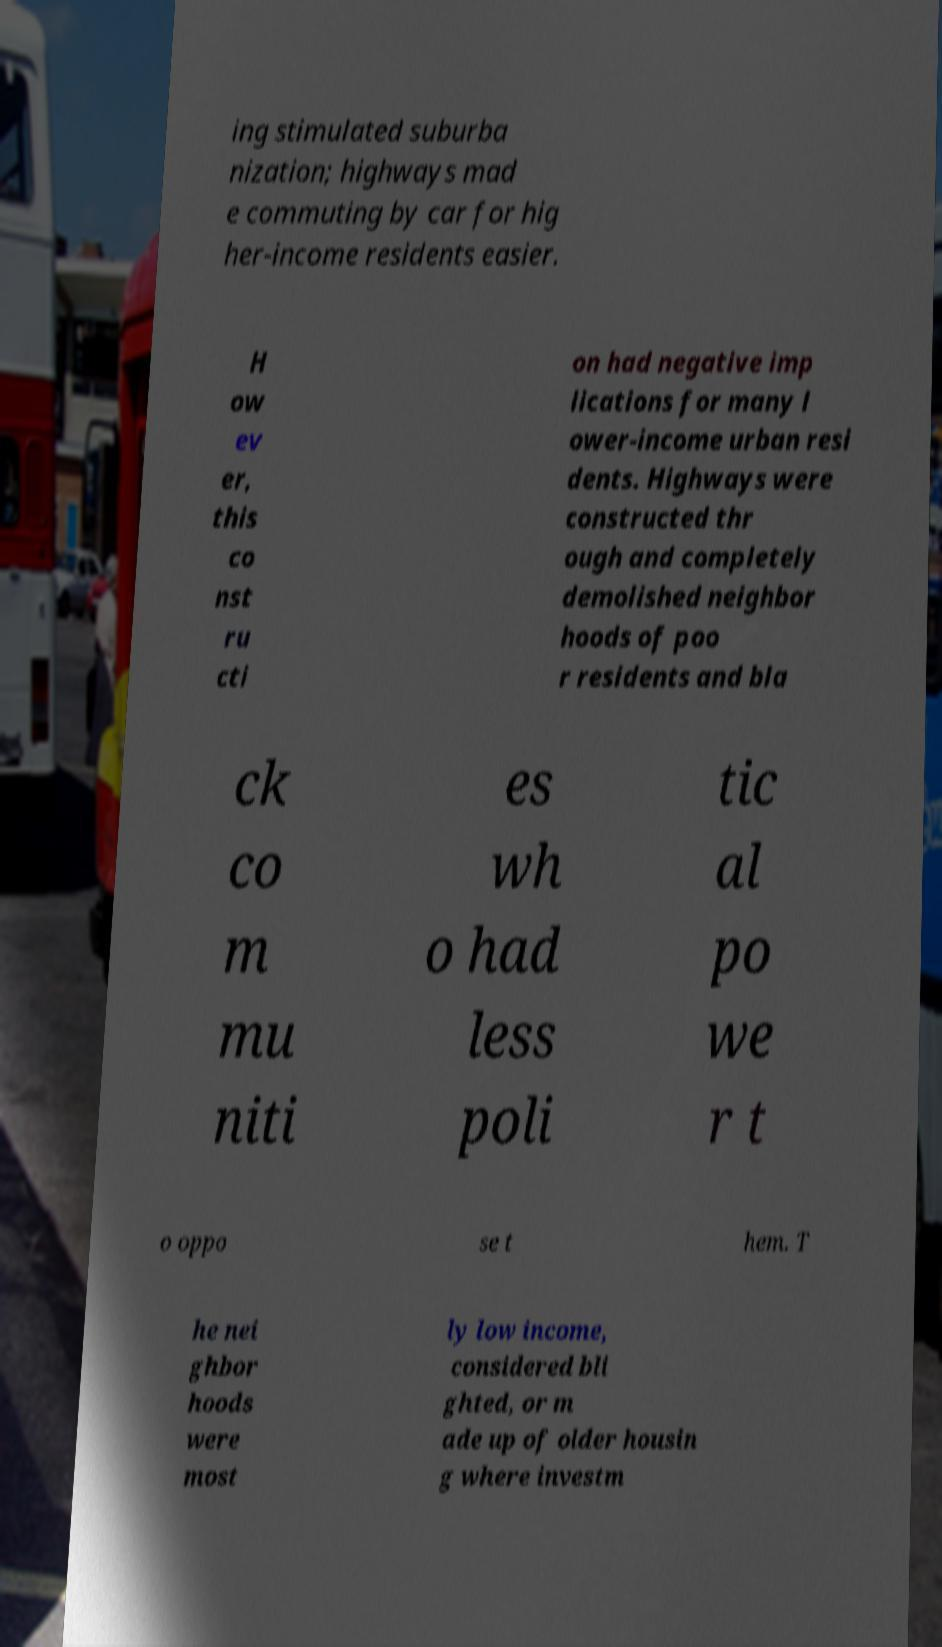Please read and relay the text visible in this image. What does it say? ing stimulated suburba nization; highways mad e commuting by car for hig her-income residents easier. H ow ev er, this co nst ru cti on had negative imp lications for many l ower-income urban resi dents. Highways were constructed thr ough and completely demolished neighbor hoods of poo r residents and bla ck co m mu niti es wh o had less poli tic al po we r t o oppo se t hem. T he nei ghbor hoods were most ly low income, considered bli ghted, or m ade up of older housin g where investm 